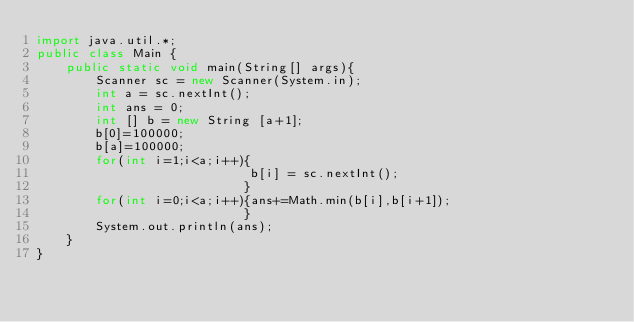<code> <loc_0><loc_0><loc_500><loc_500><_Java_>import java.util.*;
public class Main {
	public static void main(String[] args){
		Scanner sc = new Scanner(System.in);
		int a = sc.nextInt();
		int ans = 0;
        int [] b = new String [a+1];
        b[0]=100000;
        b[a]=100000;
        for(int i=1;i<a;i++){
                             b[i] = sc.nextInt();
                            }
        for(int i=0;i<a;i++){ans+=Math.min(b[i],b[i+1]);
                            }       
		System.out.println(ans);
	}
}
</code> 